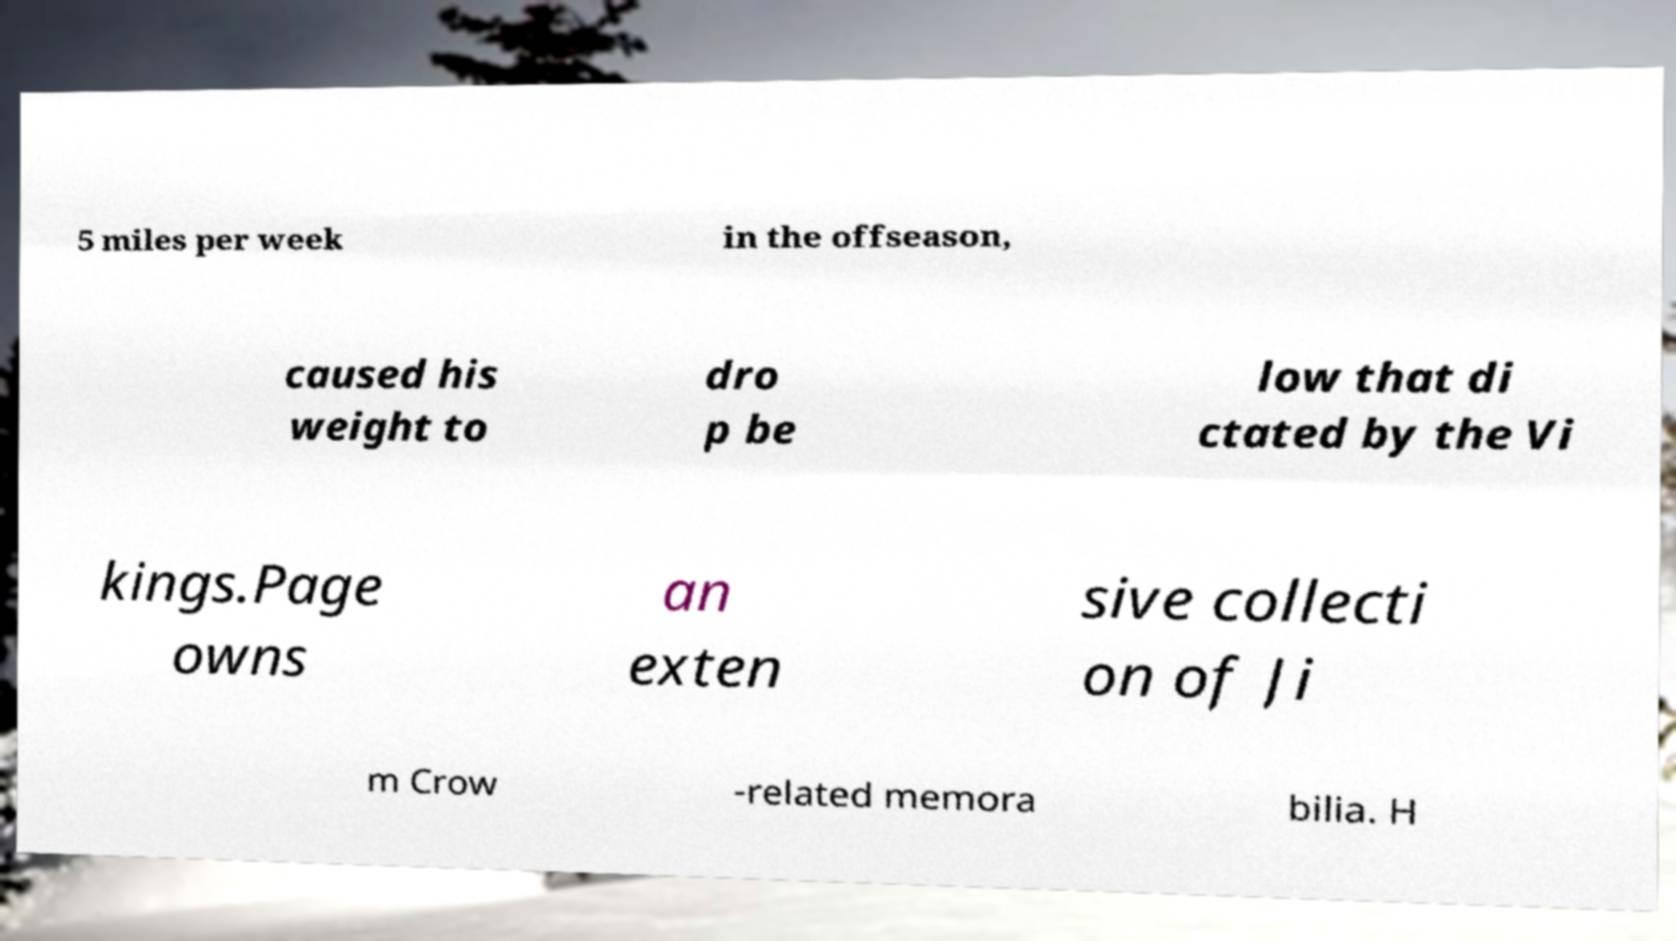Please read and relay the text visible in this image. What does it say? 5 miles per week in the offseason, caused his weight to dro p be low that di ctated by the Vi kings.Page owns an exten sive collecti on of Ji m Crow -related memora bilia. H 